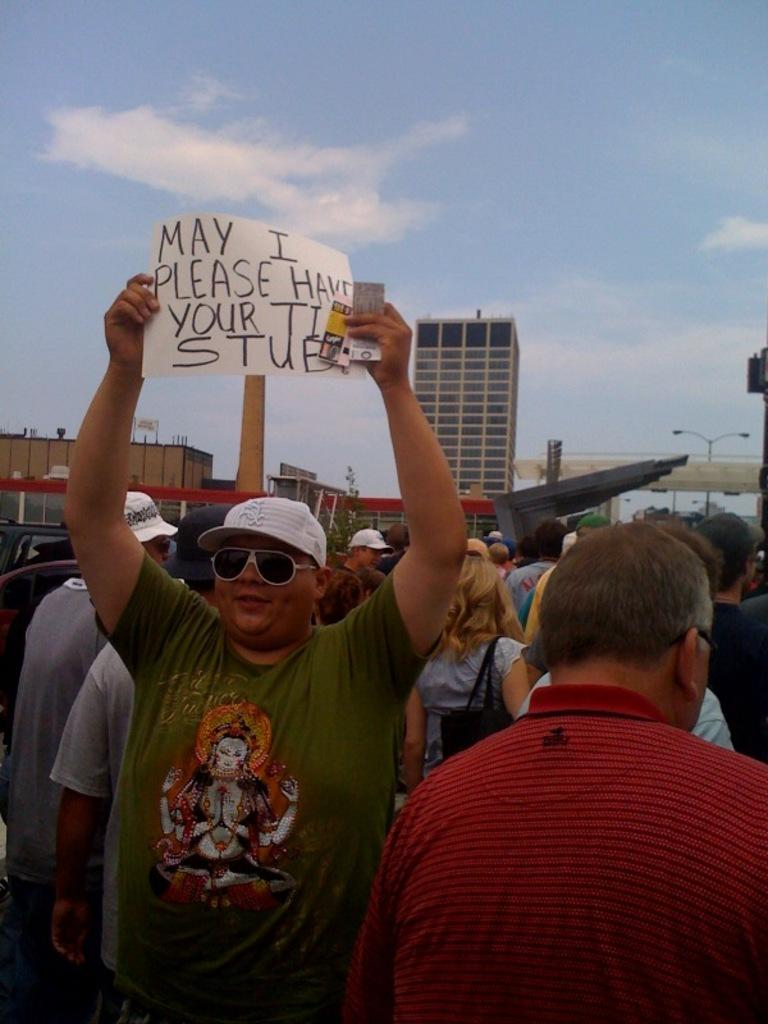What are the people at the bottom of the image doing? The people are standing at the bottom of the image and holding banners. What can be seen on the poles in the image? The banners are attached to the poles in the image. What is visible in the background of the image? There are buildings in the background of the image. What is visible in the sky in the image? There are clouds in the sky, and the sky is visible at the top of the image. What type of rock is being claimed by the people in the image? There is no rock present in the image; the people are holding banners. What body of water is visible in the image? There is no body of water visible in the image. 